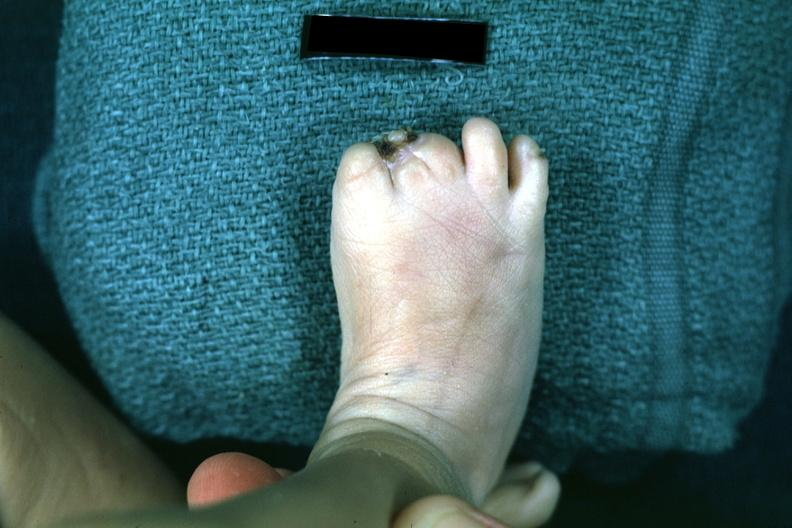s hemorrhage in newborn present?
Answer the question using a single word or phrase. No 